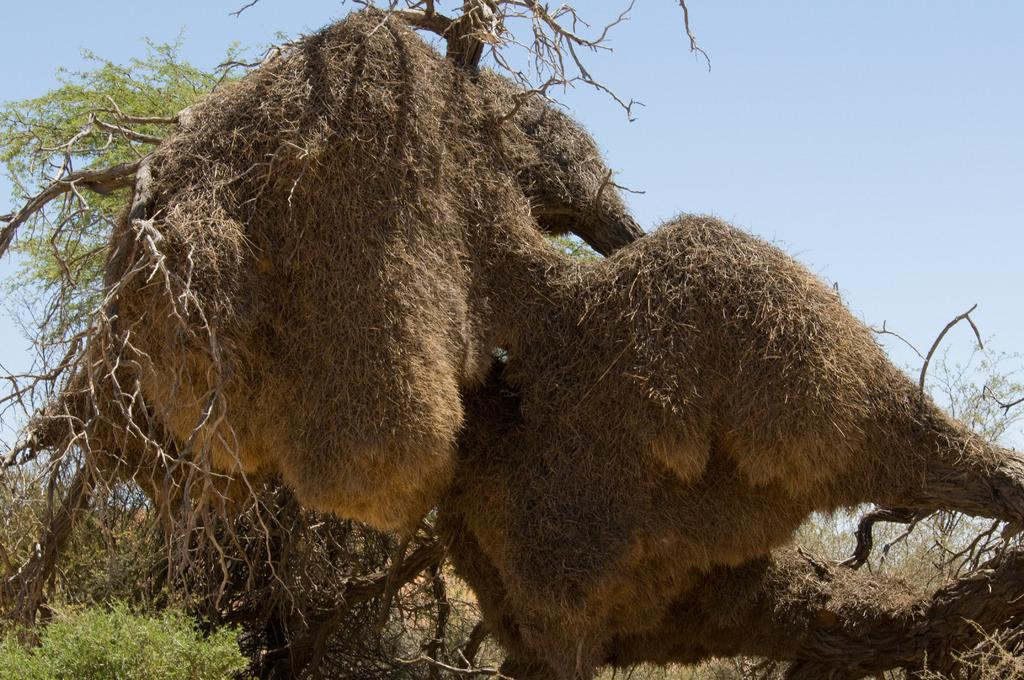What types of vegetation can be seen in the foreground of the picture? There are plants and trees in the foreground of the picture. What is the condition of the grass in the foreground? Dry grass is present in the foreground of the picture. What is visible at the top of the image? The sky is visible at the top of the image. What type of thread is being used to weave the snail's shell in the image? There is no snail or thread present in the image; it features plants, trees, and dry grass in the foreground, with the sky visible at the top. What type of rice is being grown in the foreground of the image? There is no rice present in the image; it features plants, trees, and dry grass in the foreground, with the sky visible at the top. 